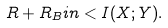Convert formula to latex. <formula><loc_0><loc_0><loc_500><loc_500>R + R _ { B } i n < I ( X ; Y ) .</formula> 